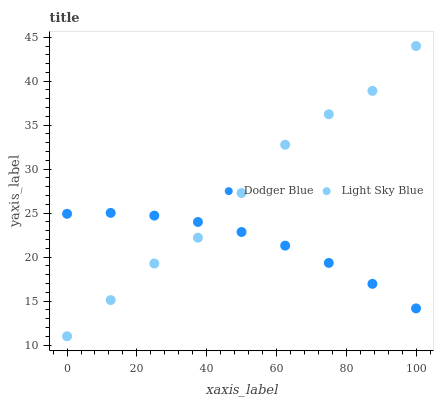Does Dodger Blue have the minimum area under the curve?
Answer yes or no. Yes. Does Light Sky Blue have the maximum area under the curve?
Answer yes or no. Yes. Does Dodger Blue have the maximum area under the curve?
Answer yes or no. No. Is Dodger Blue the smoothest?
Answer yes or no. Yes. Is Light Sky Blue the roughest?
Answer yes or no. Yes. Is Dodger Blue the roughest?
Answer yes or no. No. Does Light Sky Blue have the lowest value?
Answer yes or no. Yes. Does Dodger Blue have the lowest value?
Answer yes or no. No. Does Light Sky Blue have the highest value?
Answer yes or no. Yes. Does Dodger Blue have the highest value?
Answer yes or no. No. Does Light Sky Blue intersect Dodger Blue?
Answer yes or no. Yes. Is Light Sky Blue less than Dodger Blue?
Answer yes or no. No. Is Light Sky Blue greater than Dodger Blue?
Answer yes or no. No. 